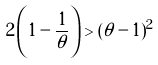<formula> <loc_0><loc_0><loc_500><loc_500>2 \left ( 1 - \frac { 1 } { \theta } \right ) > ( \theta - 1 ) ^ { 2 }</formula> 